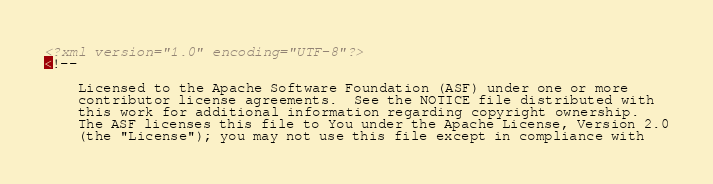Convert code to text. <code><loc_0><loc_0><loc_500><loc_500><_XML_><?xml version="1.0" encoding="UTF-8"?>
<!--

    Licensed to the Apache Software Foundation (ASF) under one or more
    contributor license agreements.  See the NOTICE file distributed with
    this work for additional information regarding copyright ownership.
    The ASF licenses this file to You under the Apache License, Version 2.0
    (the "License"); you may not use this file except in compliance with</code> 